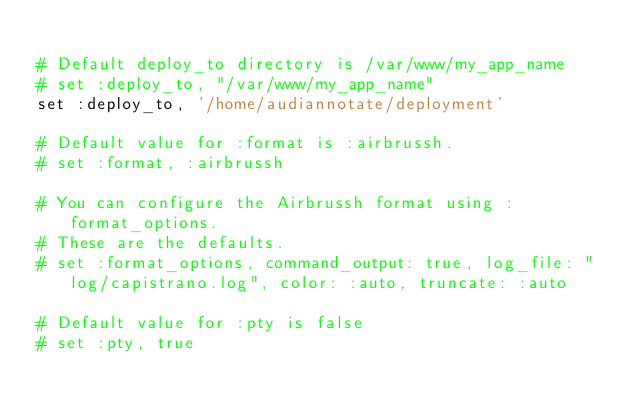Convert code to text. <code><loc_0><loc_0><loc_500><loc_500><_Ruby_>
# Default deploy_to directory is /var/www/my_app_name
# set :deploy_to, "/var/www/my_app_name"
set :deploy_to, '/home/audiannotate/deployment'

# Default value for :format is :airbrussh.
# set :format, :airbrussh

# You can configure the Airbrussh format using :format_options.
# These are the defaults.
# set :format_options, command_output: true, log_file: "log/capistrano.log", color: :auto, truncate: :auto

# Default value for :pty is false
# set :pty, true
</code> 